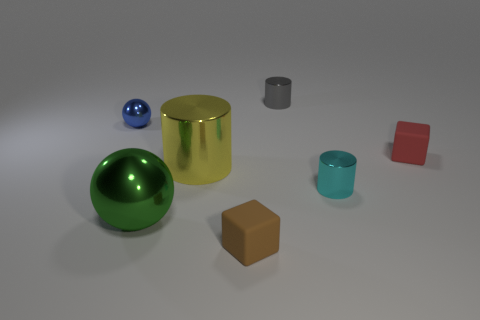Could you explain the lighting in the scene? The lighting in the scene is soft and diffused, coming from the upper left corner, as indicated by the shadows cast to the lower right of the objects. This creates gentle highlights and indicates an ambient light source outside of the frame. 